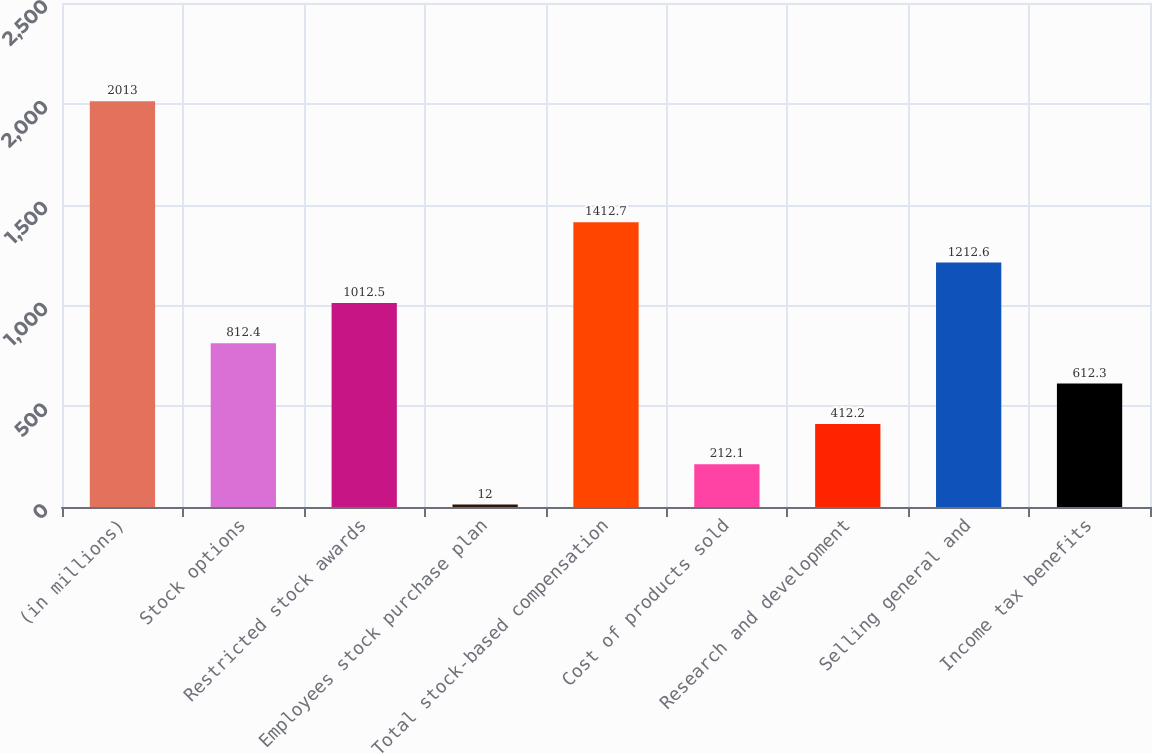Convert chart to OTSL. <chart><loc_0><loc_0><loc_500><loc_500><bar_chart><fcel>(in millions)<fcel>Stock options<fcel>Restricted stock awards<fcel>Employees stock purchase plan<fcel>Total stock-based compensation<fcel>Cost of products sold<fcel>Research and development<fcel>Selling general and<fcel>Income tax benefits<nl><fcel>2013<fcel>812.4<fcel>1012.5<fcel>12<fcel>1412.7<fcel>212.1<fcel>412.2<fcel>1212.6<fcel>612.3<nl></chart> 